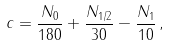<formula> <loc_0><loc_0><loc_500><loc_500>c = \frac { N _ { 0 } } { 1 8 0 } + \frac { N _ { 1 / 2 } } { 3 0 } - \frac { N _ { 1 } } { 1 0 } \, ,</formula> 